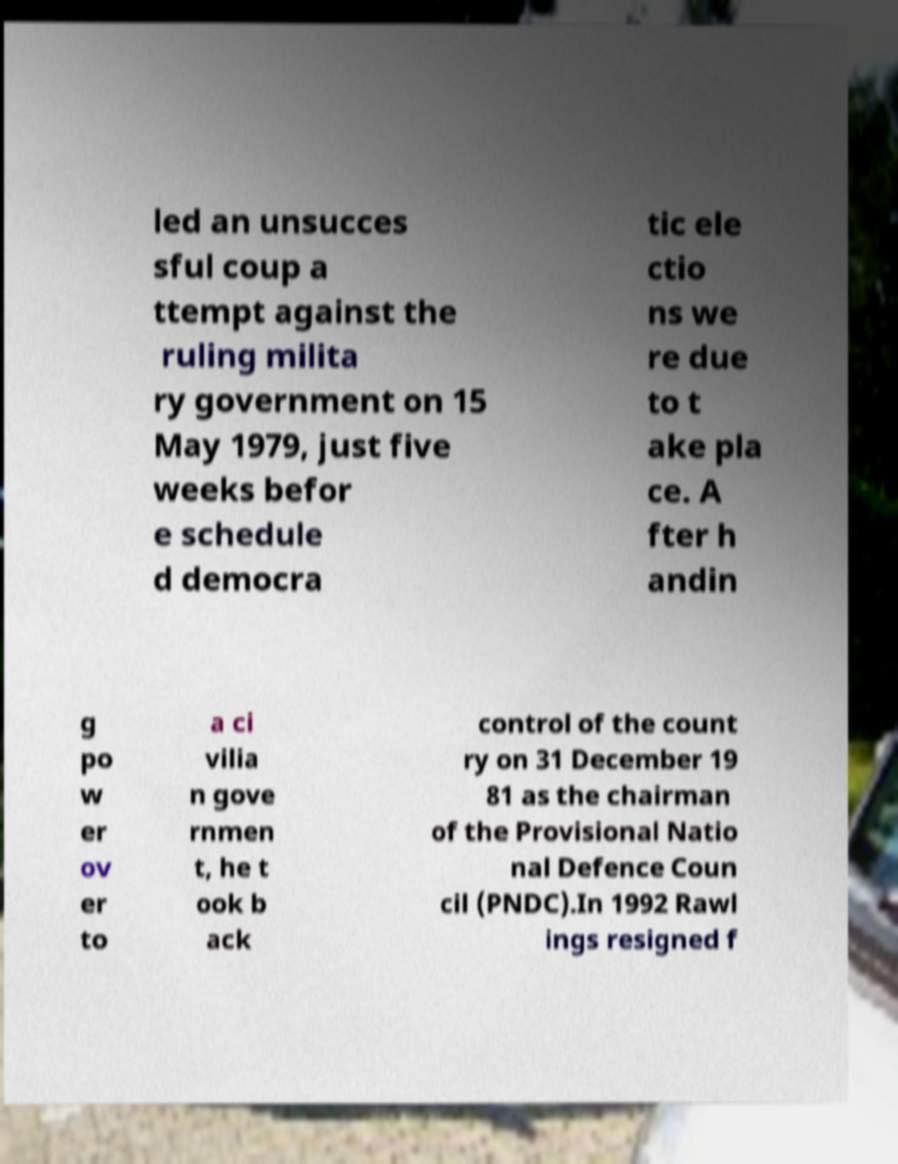What messages or text are displayed in this image? I need them in a readable, typed format. led an unsucces sful coup a ttempt against the ruling milita ry government on 15 May 1979, just five weeks befor e schedule d democra tic ele ctio ns we re due to t ake pla ce. A fter h andin g po w er ov er to a ci vilia n gove rnmen t, he t ook b ack control of the count ry on 31 December 19 81 as the chairman of the Provisional Natio nal Defence Coun cil (PNDC).In 1992 Rawl ings resigned f 